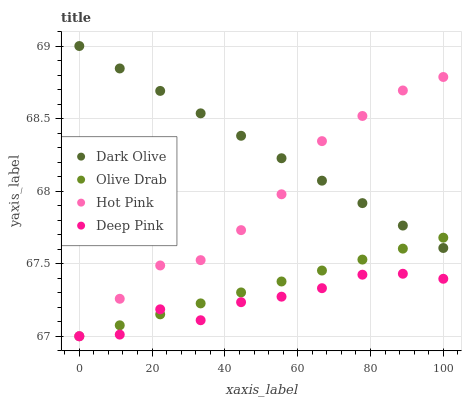Does Deep Pink have the minimum area under the curve?
Answer yes or no. Yes. Does Dark Olive have the maximum area under the curve?
Answer yes or no. Yes. Does Olive Drab have the minimum area under the curve?
Answer yes or no. No. Does Olive Drab have the maximum area under the curve?
Answer yes or no. No. Is Dark Olive the smoothest?
Answer yes or no. Yes. Is Deep Pink the roughest?
Answer yes or no. Yes. Is Olive Drab the smoothest?
Answer yes or no. No. Is Olive Drab the roughest?
Answer yes or no. No. Does Deep Pink have the lowest value?
Answer yes or no. Yes. Does Dark Olive have the highest value?
Answer yes or no. Yes. Does Olive Drab have the highest value?
Answer yes or no. No. Is Deep Pink less than Dark Olive?
Answer yes or no. Yes. Is Dark Olive greater than Deep Pink?
Answer yes or no. Yes. Does Dark Olive intersect Hot Pink?
Answer yes or no. Yes. Is Dark Olive less than Hot Pink?
Answer yes or no. No. Is Dark Olive greater than Hot Pink?
Answer yes or no. No. Does Deep Pink intersect Dark Olive?
Answer yes or no. No. 